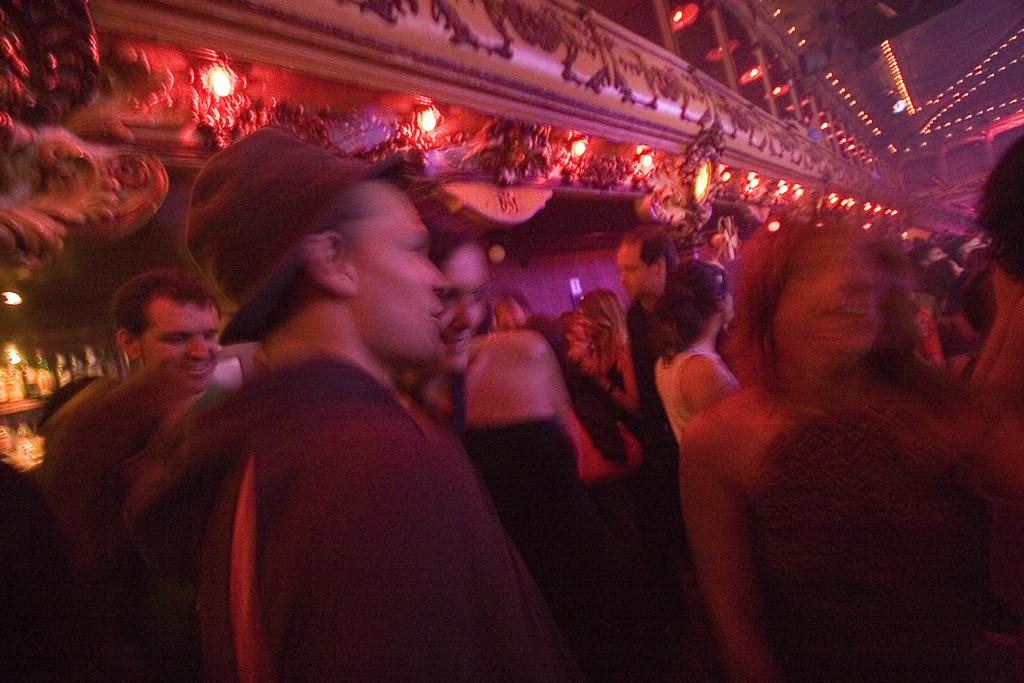What is the main subject of the image? The main subject of the image is people in the center. Can you describe the setting in which the people are located? There is a corridor with lights at the top of the image. How many chickens can be seen in the library in the image? There is no library or chickens present in the image. 